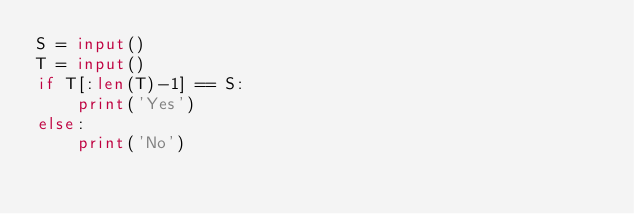Convert code to text. <code><loc_0><loc_0><loc_500><loc_500><_Python_>S = input()
T = input()
if T[:len(T)-1] == S:
    print('Yes')
else:
    print('No')</code> 